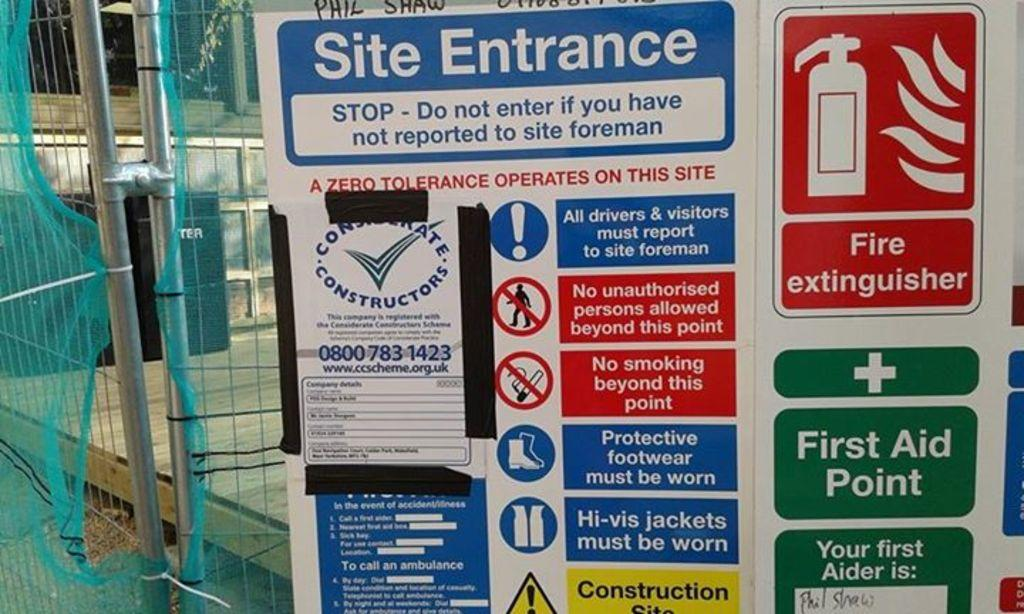<image>
Share a concise interpretation of the image provided. A sign for the site entrance and a fire extinguisher. 